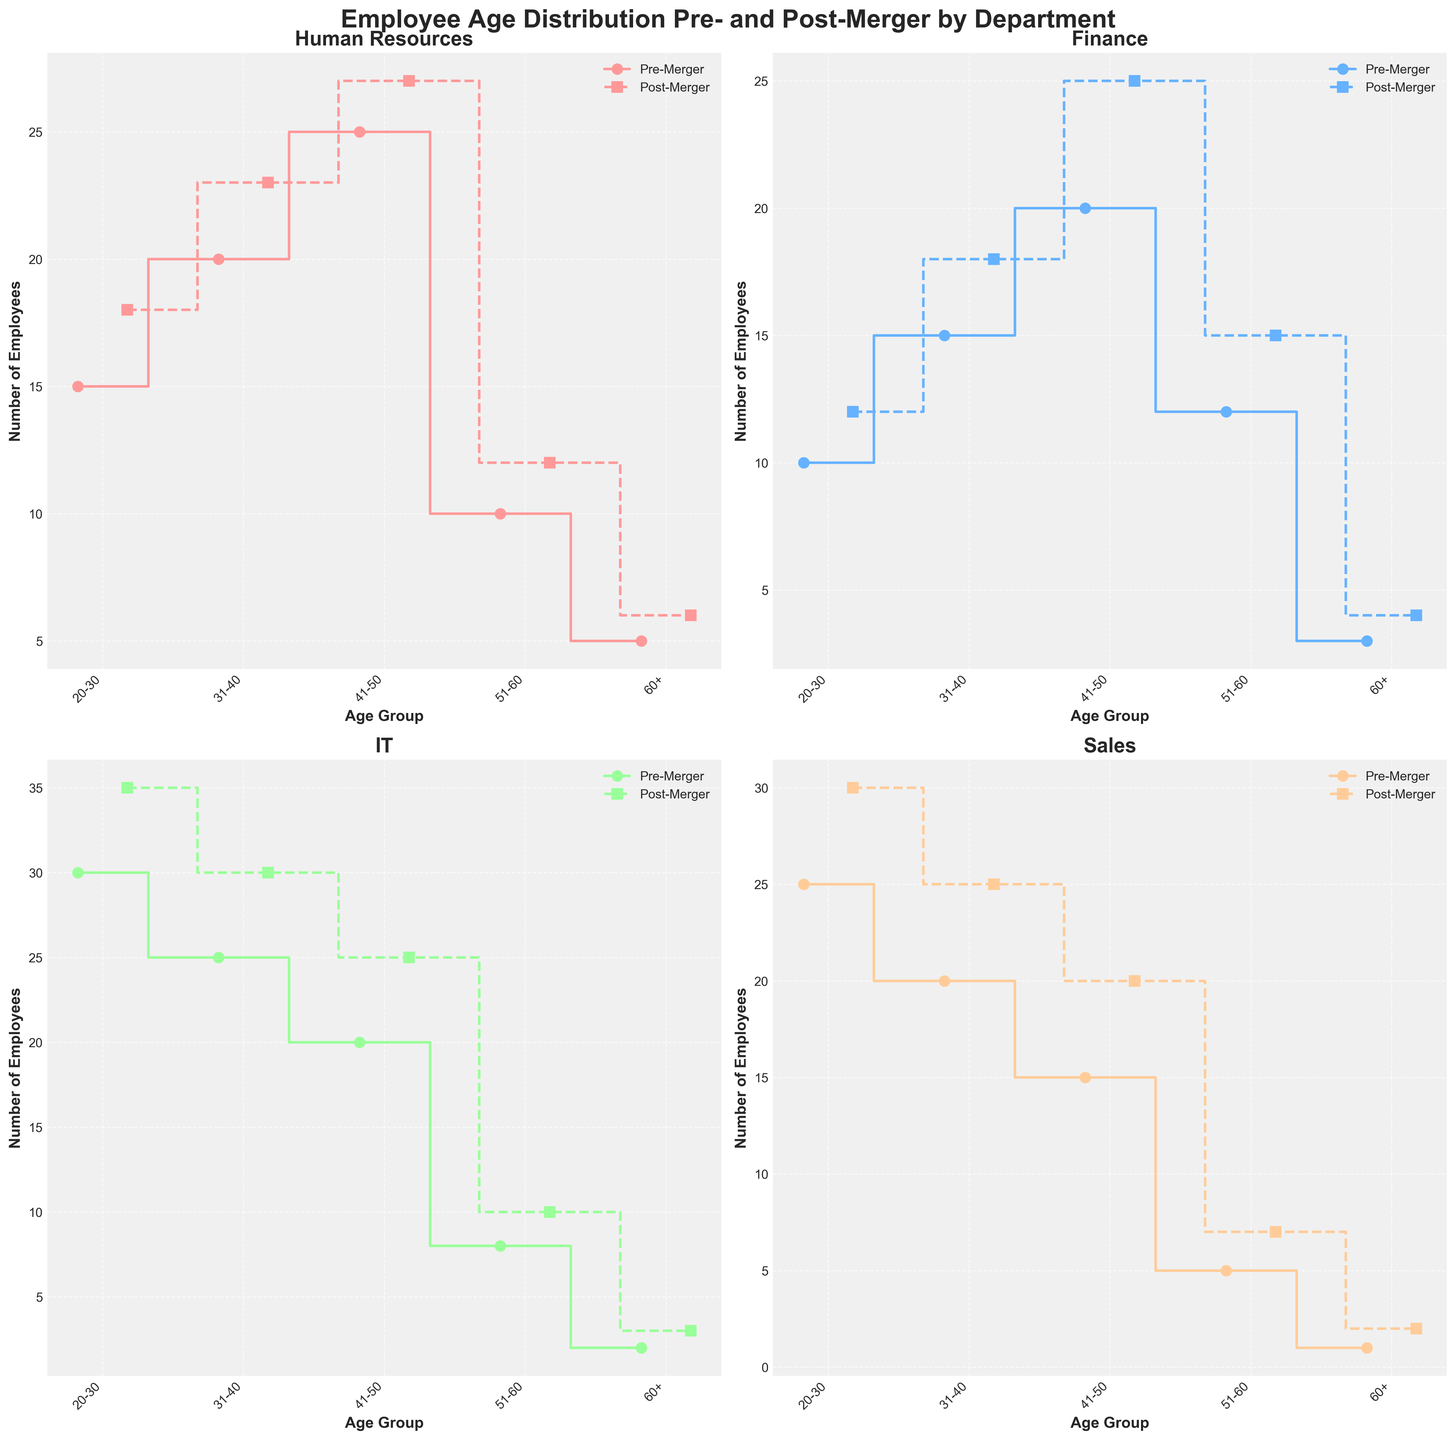What departments are displayed in the figure? The figure includes four subplots for different departments. By examining the titles of the subplots, we can identify the departments shown.
Answer: Human Resources, Finance, IT, Sales Which department has the highest number of employees in the 20-30 age group post-merger? By comparing the '20-30' age group data across all departments in the post-merger segments, we can see that IT has the highest value with 35 employees.
Answer: IT What is the overall trend in the number of employees for all departments post-merger compared to pre-merger? By examining the stair steps for each department, we can observe that generally, the steps for post-merger data are higher than for pre-merger data. This indicates an overall increase in the number of employees in each age group post-merger.
Answer: Increase What is the difference in the number of employees in the 41-50 age group pre- and post-merger for the Finance department? In the Finance department plot, the pre-merger amount is 20, and the post-merger amount is 25. The difference between these two values is 25 - 20 = 5.
Answer: 5 Which department shows the smallest change in the 60+ age group pre- and post-merger? By comparing the difference in the '60+' age group across departments, we notice that the Human Resources department changes from 5 to 6, the smallest change of +1.
Answer: Human Resources How does the age distribution of employees in Sales post-merger compare to pre-merger in the 51-60 age group? The stair plot for Sales shows that in the 51-60 age group, the number of employees pre-merger is 5, while post-merger it is 7. This shows an increase in the number of employees by 2.
Answer: Increase by 2 In the IT department, which age group experienced the largest numerical increase in the number of employees post-merger? Checking the differences for each age group in the IT department, the '20-30' age group increased from 30 to 35, which is the largest increase of +5 employees.
Answer: 20-30 Which age group in Human Resources has the most employees post-merger? By looking at the Human Resources stair plot post-merger, the age group '41-50' has the highest number of employees, totaling 27.
Answer: 41-50 Compare the trends in employee numbers between the Finance and Sales departments for the 31-40 age group, pre- and post-merger. The Finance department shows an increase from 15 to 18, while the Sales department shows an increase from 20 to 25. Both departments experience an increase in the number of employees, but Sales has a larger absolute increase of +5 compared to Finance's +3.
Answer: Both increase; Sales increases more What is the total number of employees in the IT department pre-merger? Summing the pre-merger values for '20-30', '31-40', '41-50', '51-60', and '60+' age groups in IT: 30 + 25 + 20 + 8 + 2 = 85.
Answer: 85 